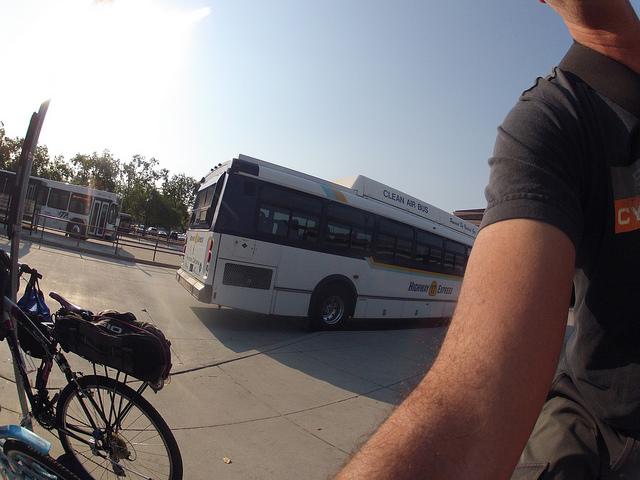How many bicycles are visible in this photo?
Give a very brief answer. 1. What shipping truck is in the background?
Answer briefly. Fedex. Can you see a blue car?
Answer briefly. No. Who does the man work for?
Write a very short answer. Can't tell. What is the guy riding?
Give a very brief answer. Bike. Is the bus chained?
Short answer required. No. Who is riding the bike with a bird?
Answer briefly. Man. How many bikes does he have?
Give a very brief answer. 1. What color is the bike?
Give a very brief answer. Black. Is there a bike in the picture?
Give a very brief answer. Yes. Did the man take this picture himself?
Quick response, please. Yes. Do the weather appear to be cold?
Give a very brief answer. No. Where is the bus?
Concise answer only. On road. Does the biker have a fanny pack?
Concise answer only. No. Was the photo taken on a park?
Write a very short answer. No. Are there hedges in the scene?
Write a very short answer. No. What method of transport is shown?
Answer briefly. Bus. What kind of transportation is visible?
Short answer required. Bus. Do you see a brick building?
Give a very brief answer. No. What style bike is this?
Answer briefly. Mountain. What is the man tugging?
Concise answer only. Camera. Is the person using a traditional bicycle?
Keep it brief. Yes. Does the man have on a tee shirt underneath his shirt?
Write a very short answer. No. Are the lights on?
Answer briefly. No. What is the guy holding in front of him?
Write a very short answer. Camera. Are they shaking hands?
Quick response, please. No. What is in the background on the other side of the road?
Write a very short answer. Bus. Besides busses, what form of transportation is there?
Give a very brief answer. Bicycle. Is it windy?
Give a very brief answer. No. How many officers are in the photo?
Write a very short answer. 0. Is it a sunny day?
Write a very short answer. Yes. 